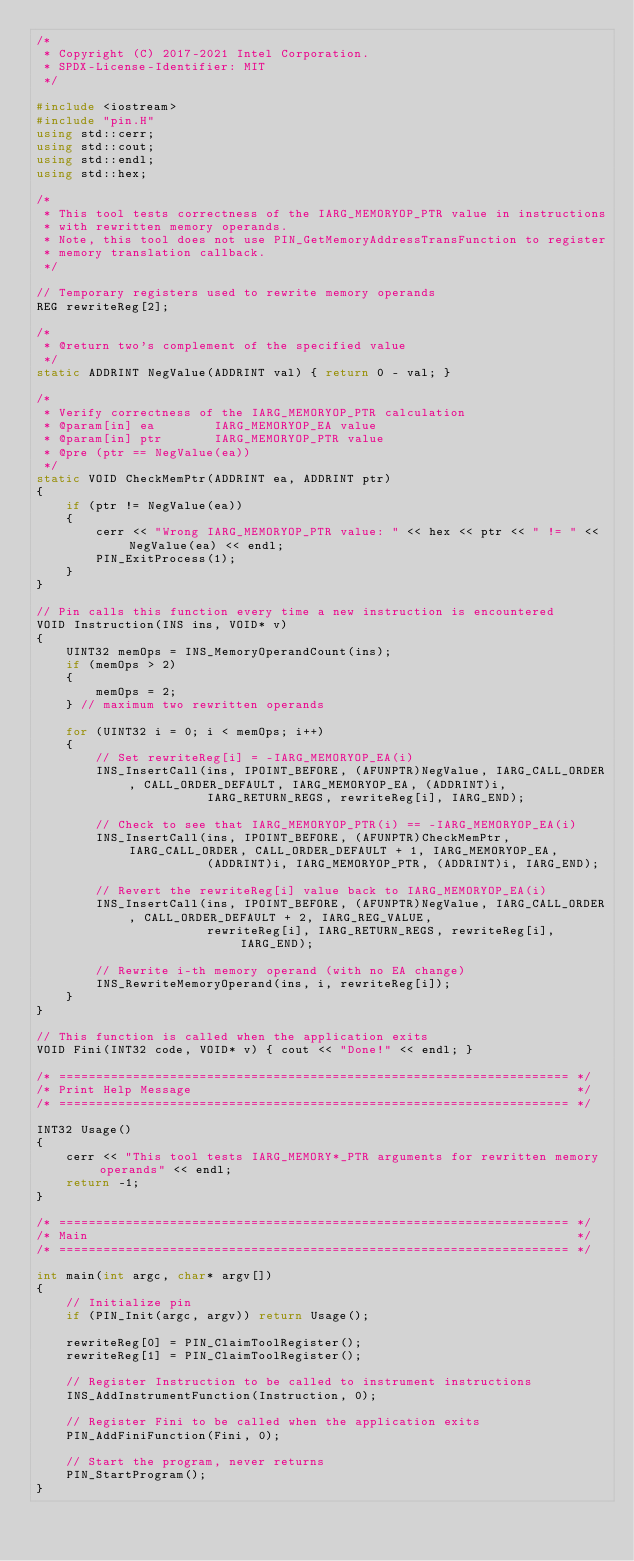Convert code to text. <code><loc_0><loc_0><loc_500><loc_500><_C++_>/*
 * Copyright (C) 2017-2021 Intel Corporation.
 * SPDX-License-Identifier: MIT
 */

#include <iostream>
#include "pin.H"
using std::cerr;
using std::cout;
using std::endl;
using std::hex;

/*
 * This tool tests correctness of the IARG_MEMORYOP_PTR value in instructions
 * with rewritten memory operands.
 * Note, this tool does not use PIN_GetMemoryAddressTransFunction to register
 * memory translation callback.
 */

// Temporary registers used to rewrite memory operands
REG rewriteReg[2];

/*
 * @return two's complement of the specified value
 */
static ADDRINT NegValue(ADDRINT val) { return 0 - val; }

/*
 * Verify correctness of the IARG_MEMORYOP_PTR calculation
 * @param[in] ea        IARG_MEMORYOP_EA value
 * @param[in] ptr       IARG_MEMORYOP_PTR value
 * @pre (ptr == NegValue(ea)) 
 */
static VOID CheckMemPtr(ADDRINT ea, ADDRINT ptr)
{
    if (ptr != NegValue(ea))
    {
        cerr << "Wrong IARG_MEMORYOP_PTR value: " << hex << ptr << " != " << NegValue(ea) << endl;
        PIN_ExitProcess(1);
    }
}

// Pin calls this function every time a new instruction is encountered
VOID Instruction(INS ins, VOID* v)
{
    UINT32 memOps = INS_MemoryOperandCount(ins);
    if (memOps > 2)
    {
        memOps = 2;
    } // maximum two rewritten operands

    for (UINT32 i = 0; i < memOps; i++)
    {
        // Set rewriteReg[i] = -IARG_MEMORYOP_EA(i)
        INS_InsertCall(ins, IPOINT_BEFORE, (AFUNPTR)NegValue, IARG_CALL_ORDER, CALL_ORDER_DEFAULT, IARG_MEMORYOP_EA, (ADDRINT)i,
                       IARG_RETURN_REGS, rewriteReg[i], IARG_END);

        // Check to see that IARG_MEMORYOP_PTR(i) == -IARG_MEMORYOP_EA(i)
        INS_InsertCall(ins, IPOINT_BEFORE, (AFUNPTR)CheckMemPtr, IARG_CALL_ORDER, CALL_ORDER_DEFAULT + 1, IARG_MEMORYOP_EA,
                       (ADDRINT)i, IARG_MEMORYOP_PTR, (ADDRINT)i, IARG_END);

        // Revert the rewriteReg[i] value back to IARG_MEMORYOP_EA(i)
        INS_InsertCall(ins, IPOINT_BEFORE, (AFUNPTR)NegValue, IARG_CALL_ORDER, CALL_ORDER_DEFAULT + 2, IARG_REG_VALUE,
                       rewriteReg[i], IARG_RETURN_REGS, rewriteReg[i], IARG_END);

        // Rewrite i-th memory operand (with no EA change)
        INS_RewriteMemoryOperand(ins, i, rewriteReg[i]);
    }
}

// This function is called when the application exits
VOID Fini(INT32 code, VOID* v) { cout << "Done!" << endl; }

/* ===================================================================== */
/* Print Help Message                                                    */
/* ===================================================================== */

INT32 Usage()
{
    cerr << "This tool tests IARG_MEMORY*_PTR arguments for rewritten memory operands" << endl;
    return -1;
}

/* ===================================================================== */
/* Main                                                                  */
/* ===================================================================== */

int main(int argc, char* argv[])
{
    // Initialize pin
    if (PIN_Init(argc, argv)) return Usage();

    rewriteReg[0] = PIN_ClaimToolRegister();
    rewriteReg[1] = PIN_ClaimToolRegister();

    // Register Instruction to be called to instrument instructions
    INS_AddInstrumentFunction(Instruction, 0);

    // Register Fini to be called when the application exits
    PIN_AddFiniFunction(Fini, 0);

    // Start the program, never returns
    PIN_StartProgram();
}
</code> 